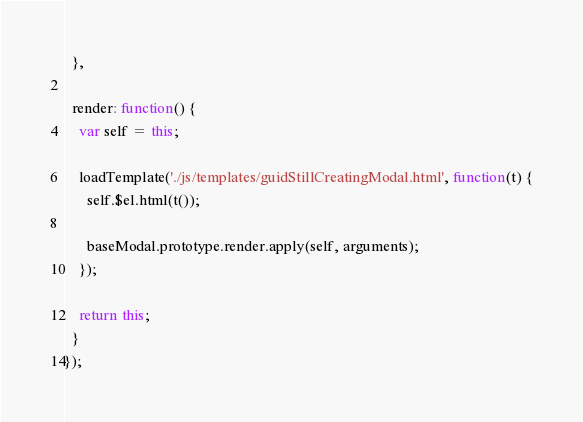<code> <loc_0><loc_0><loc_500><loc_500><_JavaScript_>  },

  render: function() {
    var self = this;

    loadTemplate('./js/templates/guidStillCreatingModal.html', function(t) {
      self.$el.html(t());

      baseModal.prototype.render.apply(self, arguments);
    });

    return this;
  }
});
</code> 